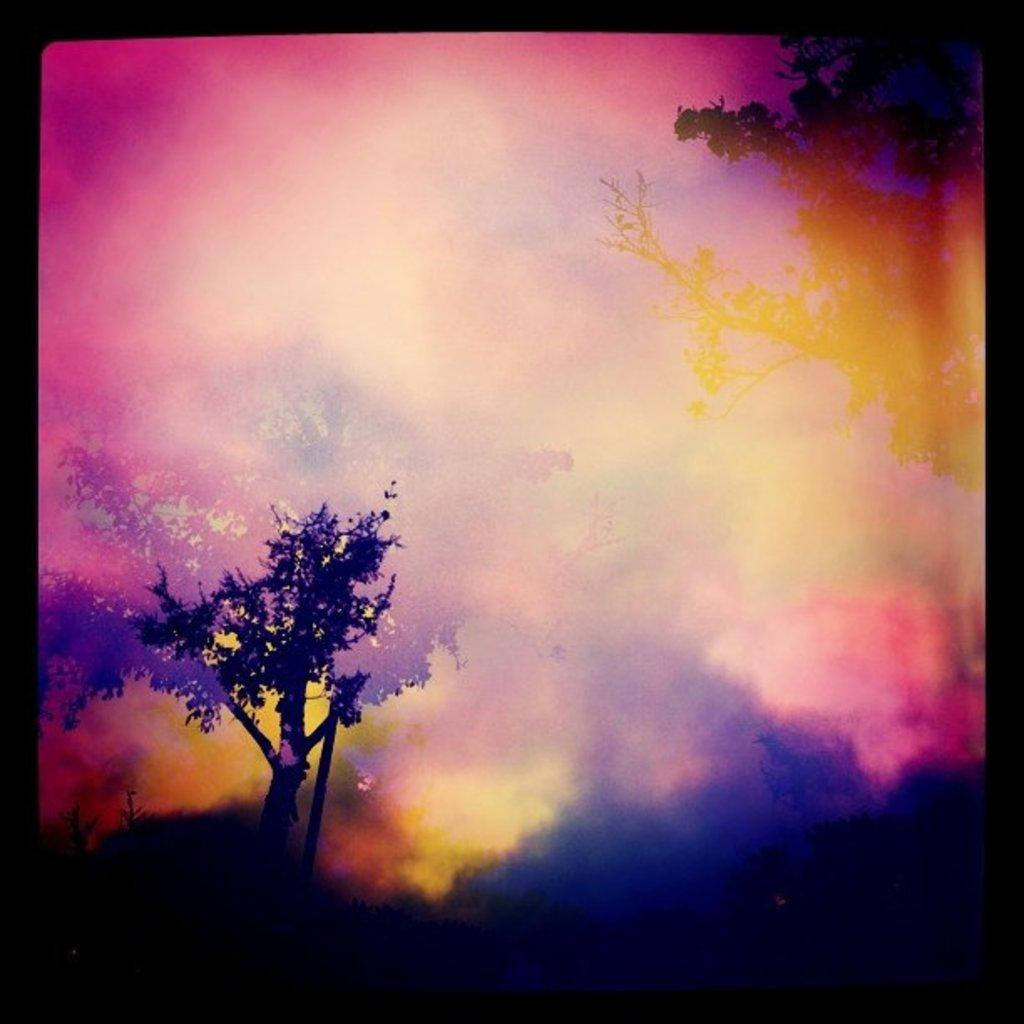What type of vegetation can be seen in the image? There are trees in the image. Can you describe the colors visible in the image? There are colors visible in the image, but without more specific information, it's difficult to provide a detailed description. How many units of kitty can be seen in the image? There are no kitties present in the image. What is the color of the tongue in the image? There is no tongue visible in the image. 